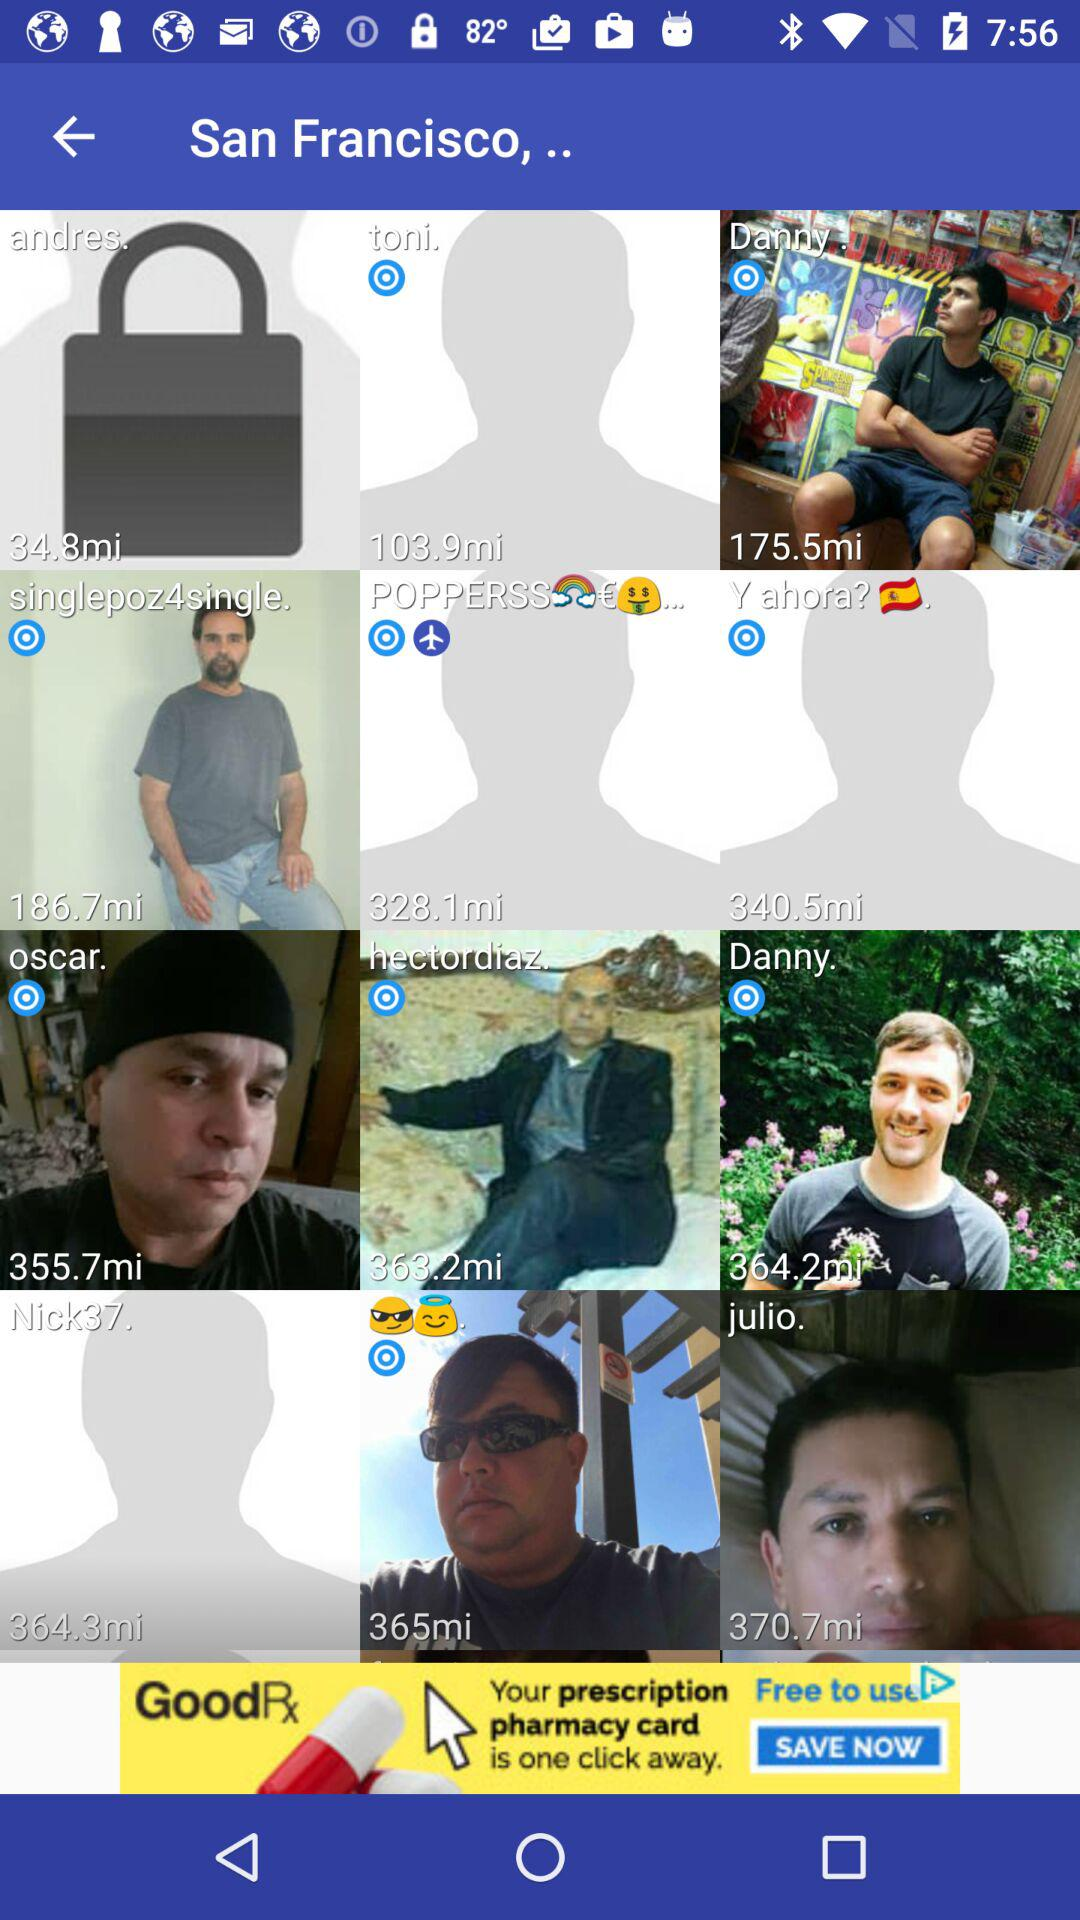What is the given location? The location is San Francisco. 